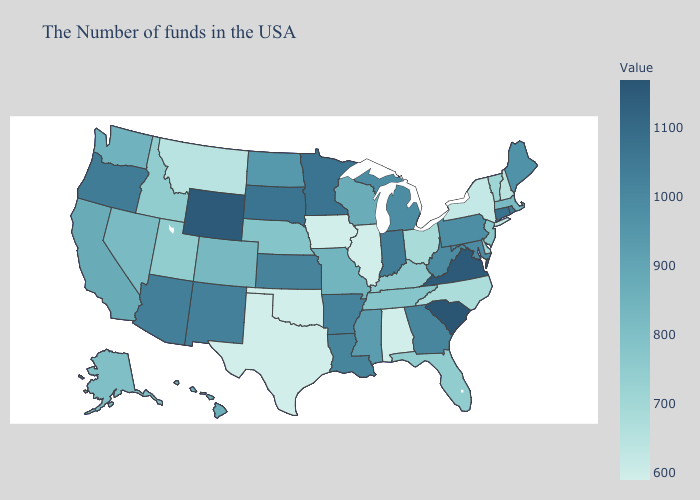Does the map have missing data?
Concise answer only. No. Does Virginia have the highest value in the USA?
Short answer required. No. Among the states that border New Jersey , does New York have the lowest value?
Keep it brief. Yes. Is the legend a continuous bar?
Short answer required. Yes. Does Texas have the lowest value in the South?
Keep it brief. Yes. Among the states that border Pennsylvania , which have the lowest value?
Write a very short answer. New York. 